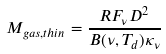Convert formula to latex. <formula><loc_0><loc_0><loc_500><loc_500>M _ { g a s , t h i n } = \frac { R F _ { \nu } D ^ { 2 } } { B ( \nu , T _ { d } ) \kappa _ { \nu } }</formula> 